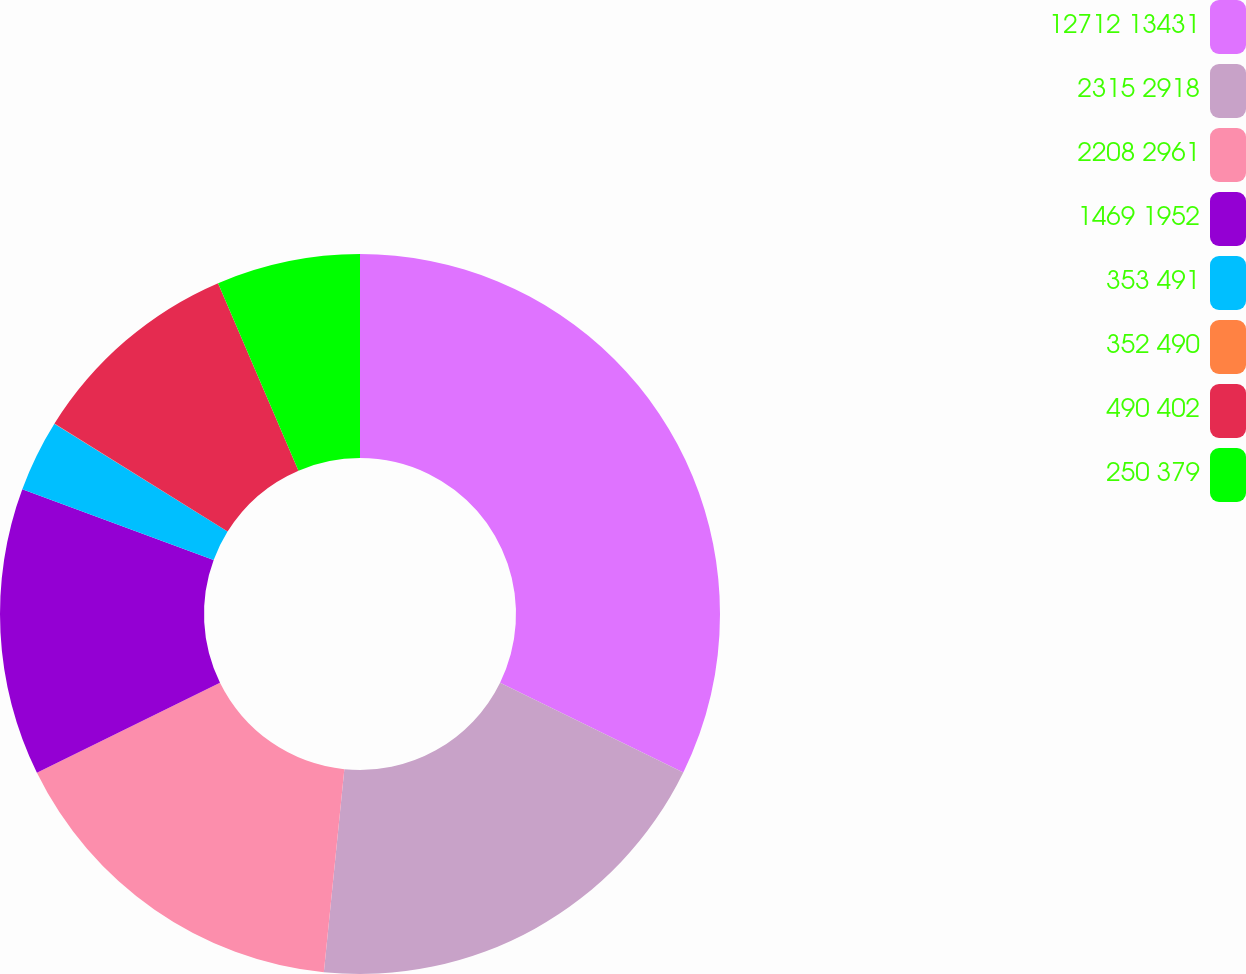<chart> <loc_0><loc_0><loc_500><loc_500><pie_chart><fcel>12712 13431<fcel>2315 2918<fcel>2208 2961<fcel>1469 1952<fcel>353 491<fcel>352 490<fcel>490 402<fcel>250 379<nl><fcel>32.25%<fcel>19.35%<fcel>16.13%<fcel>12.9%<fcel>3.23%<fcel>0.01%<fcel>9.68%<fcel>6.45%<nl></chart> 